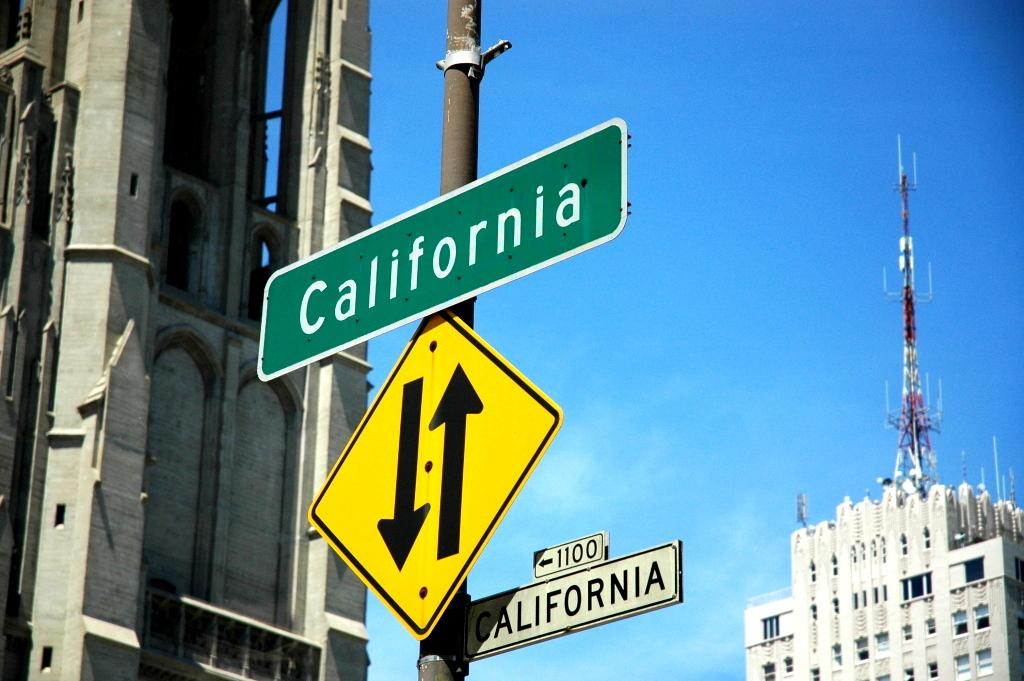<image>
Write a terse but informative summary of the picture. A gray building stands by a street sign for the 1100 block of California. 